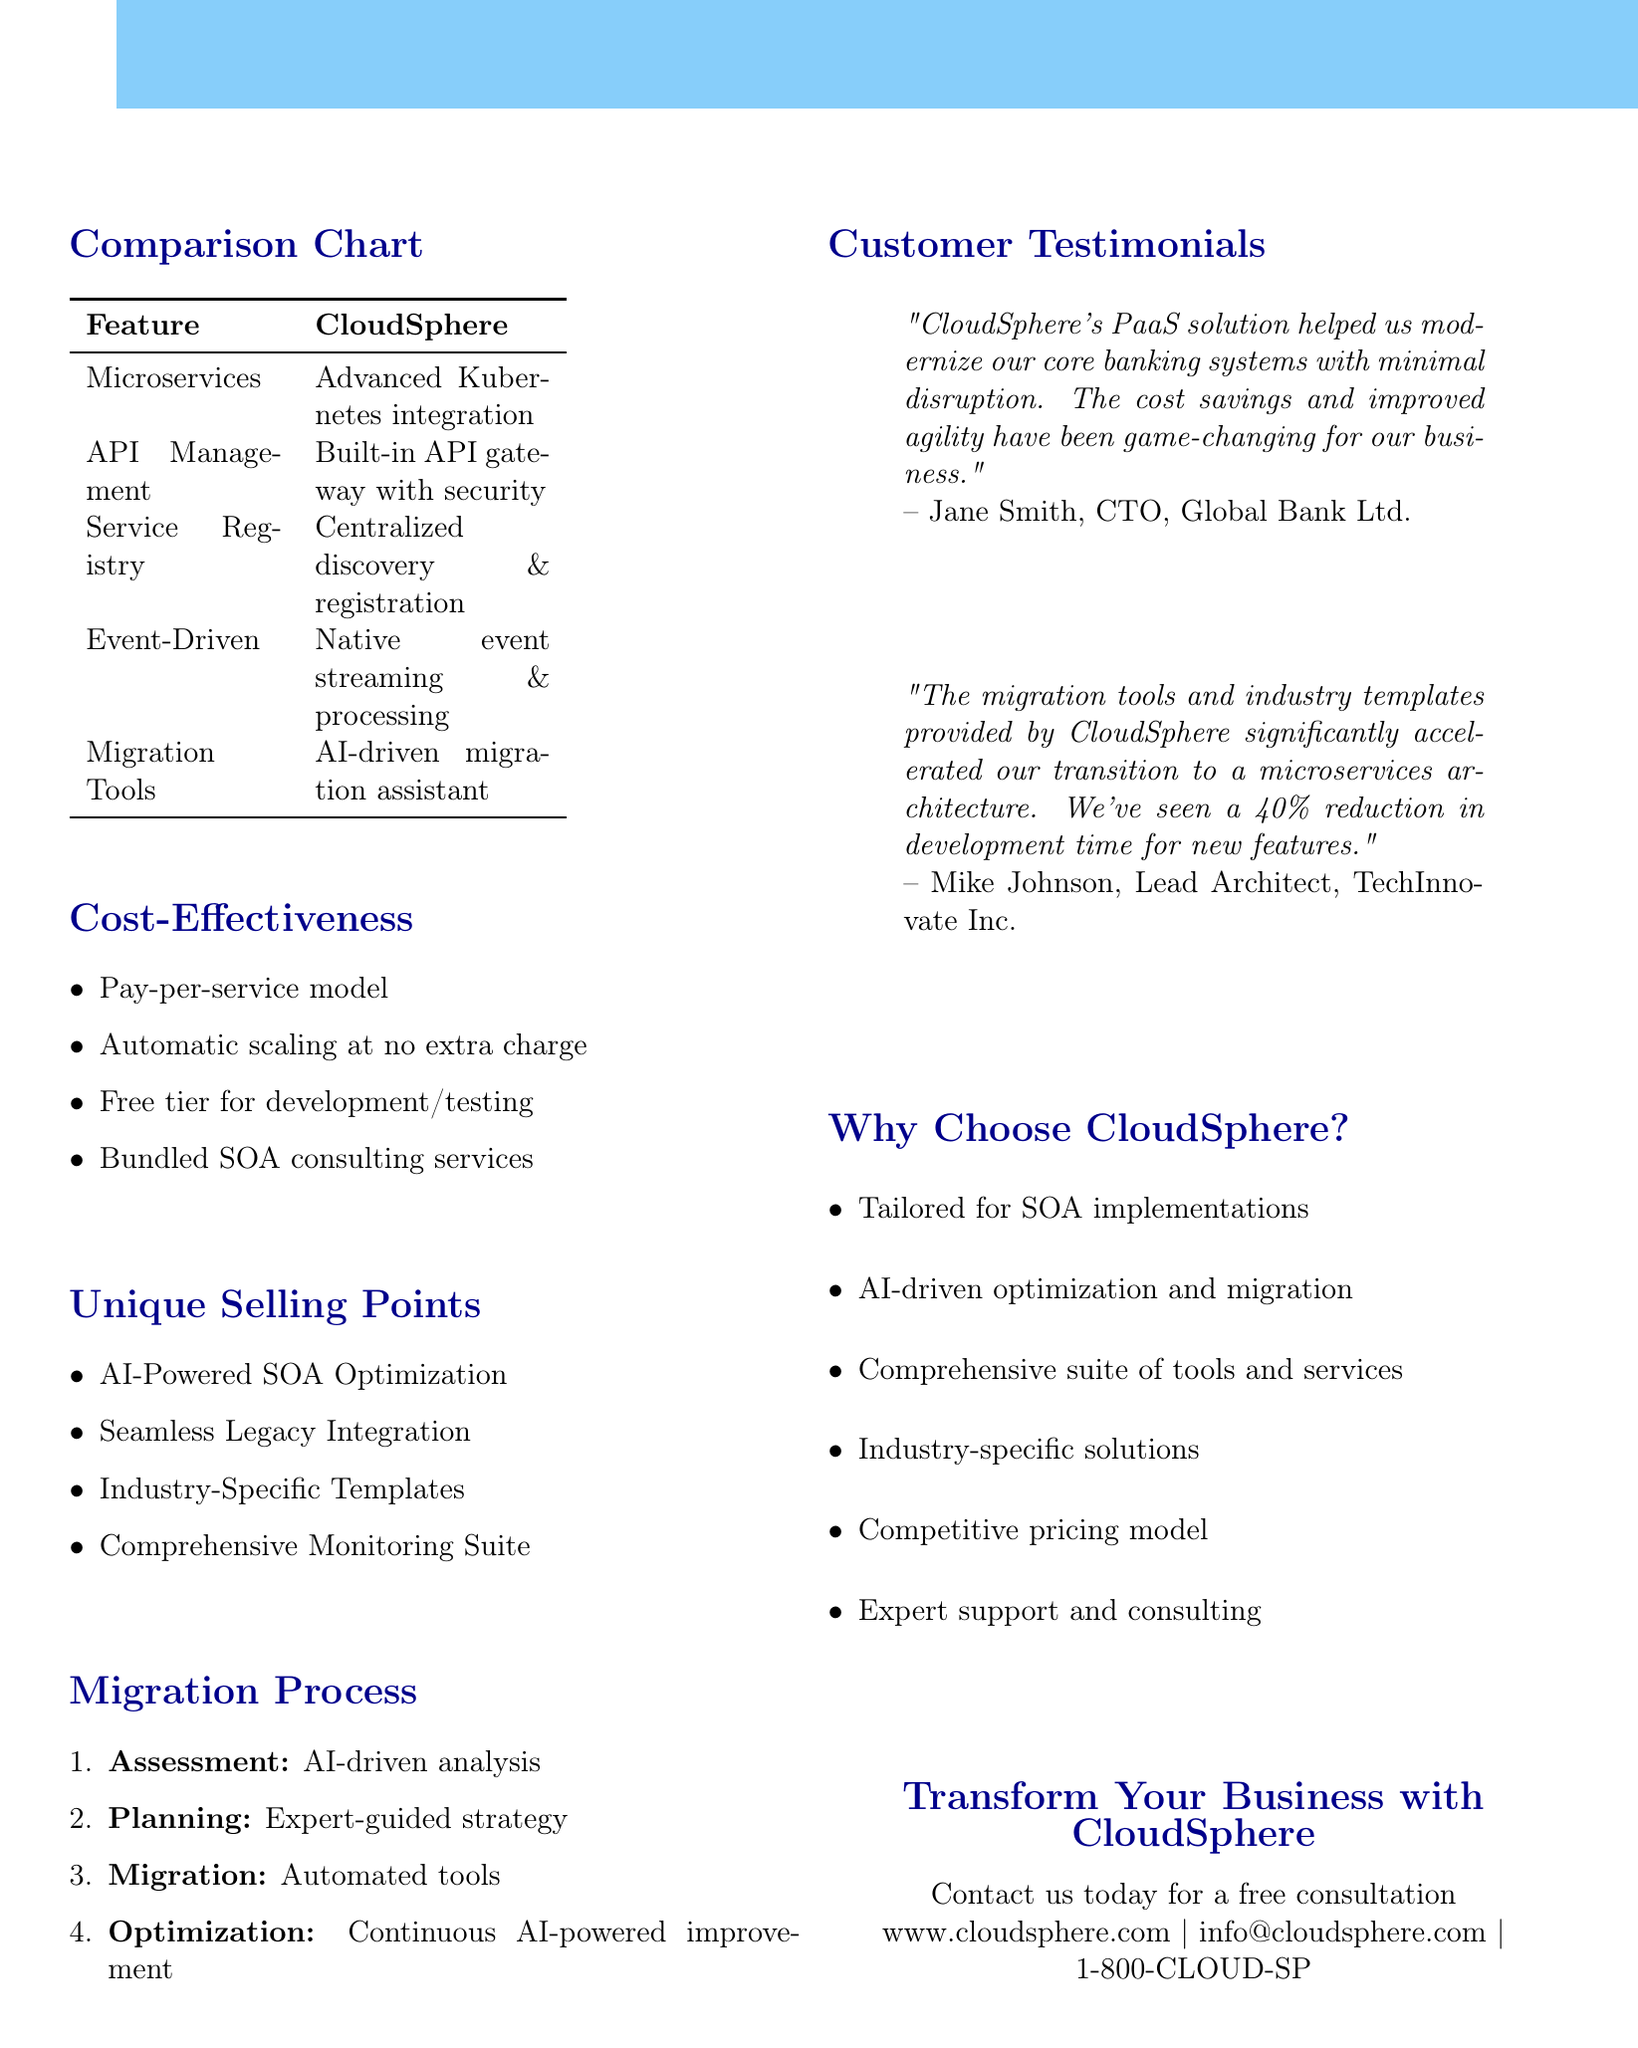What is the title of the comparison chart? The title of the comparison chart is explicitly stated in the document as "CloudSphere PaaS vs. Competitors for SOA Implementation."
Answer: CloudSphere PaaS vs. Competitors for SOA Implementation Which company offers a built-in API gateway? The feature comparison indicates that CloudSphere offers a built-in API gateway with advanced security features, making it the company responsible for this offering.
Answer: CloudSphere What unique pricing model does CloudSphere offer? In the cost-effectiveness section, it is stated that CloudSphere uses a pay-per-service model instead of instance-based pricing.
Answer: Pay-per-service model What percentage reduction in development time did TechInnovate Inc. experience? The testimonial from TechInnovate Inc. mentions a 40% reduction in development time for new features due to CloudSphere's offerings.
Answer: 40% Which step comes after "Planning" in the migration process? The migration process outlines steps in order, indicating that "Migration" follows "Planning."
Answer: Migration What is the name of the architecture CloudSphere specializes in? The document frequently emphasizes CloudSphere's offering and features tailored specifically for Service-Oriented Architecture (SOA).
Answer: Service-Oriented Architecture (SOA) Who is the CTO of Global Bank Ltd.? The customer testimonial provides the name of the CTO of Global Bank Ltd. as Jane Smith.
Answer: Jane Smith What unique feature of CloudSphere optimizes service architecture? The unique selling point section describes "AI-Powered SOA Optimization" as a feature that helps optimize the service architecture.
Answer: AI-Powered SOA Optimization 